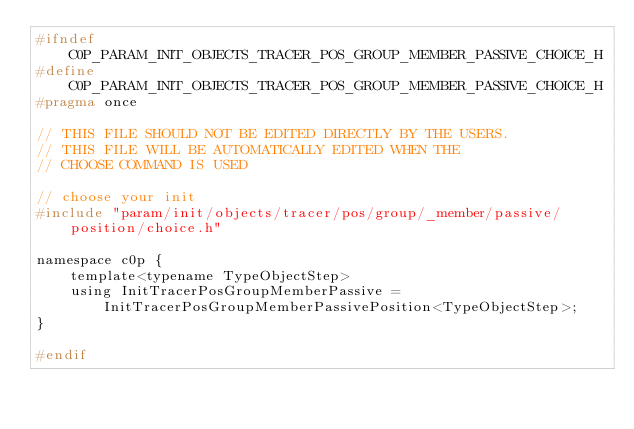Convert code to text. <code><loc_0><loc_0><loc_500><loc_500><_C_>#ifndef C0P_PARAM_INIT_OBJECTS_TRACER_POS_GROUP_MEMBER_PASSIVE_CHOICE_H
#define C0P_PARAM_INIT_OBJECTS_TRACER_POS_GROUP_MEMBER_PASSIVE_CHOICE_H
#pragma once

// THIS FILE SHOULD NOT BE EDITED DIRECTLY BY THE USERS.
// THIS FILE WILL BE AUTOMATICALLY EDITED WHEN THE
// CHOOSE COMMAND IS USED

// choose your init
#include "param/init/objects/tracer/pos/group/_member/passive/position/choice.h"

namespace c0p {
    template<typename TypeObjectStep>
    using InitTracerPosGroupMemberPassive = InitTracerPosGroupMemberPassivePosition<TypeObjectStep>;
}

#endif
</code> 